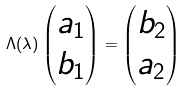Convert formula to latex. <formula><loc_0><loc_0><loc_500><loc_500>\Lambda ( \lambda ) \begin{pmatrix} a _ { 1 } \\ b _ { 1 } \end{pmatrix} = \begin{pmatrix} b _ { 2 } \\ a _ { 2 } \end{pmatrix}</formula> 